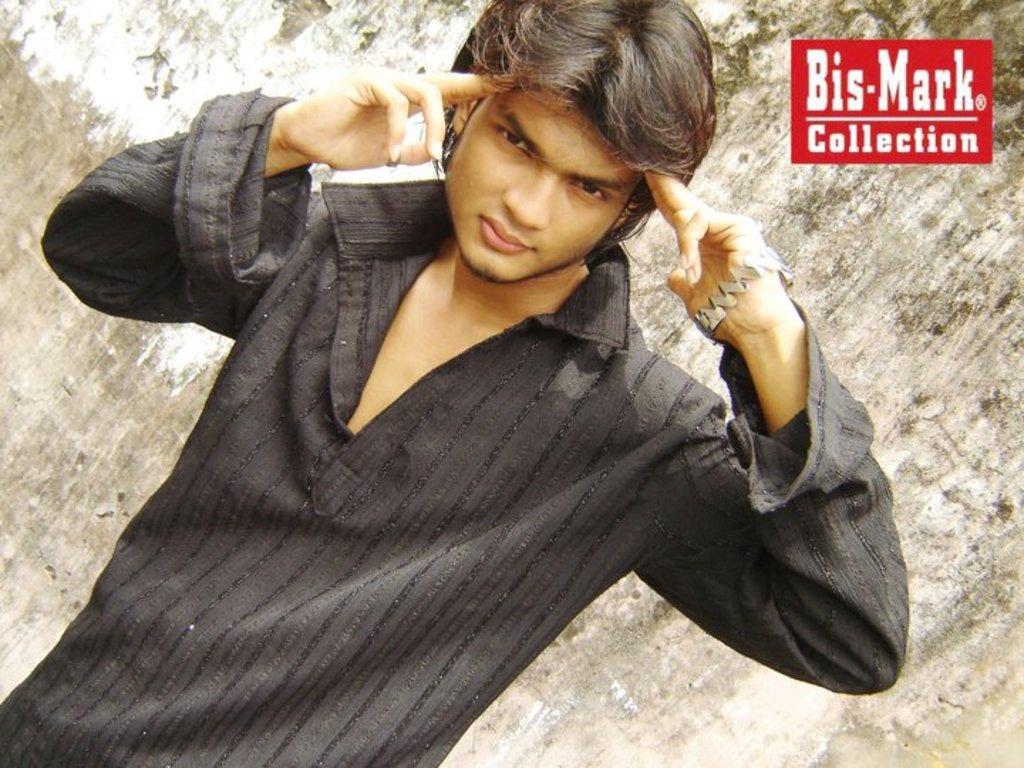Who is present in the image? There is a man in the image. What is the man wearing? The man is wearing a black dress. What can be seen in the background of the image? There is a wall in the background of the image. Is there any additional information about the image itself? Yes, there is a watermark in the right top corner of the image. What song is the man singing in the image? There is no indication in the image that the man is singing, and therefore no song can be identified. Can you tell me how many pigs are present in the image? There are no pigs present in the image; it features a man wearing a black dress with a wall in the background. 